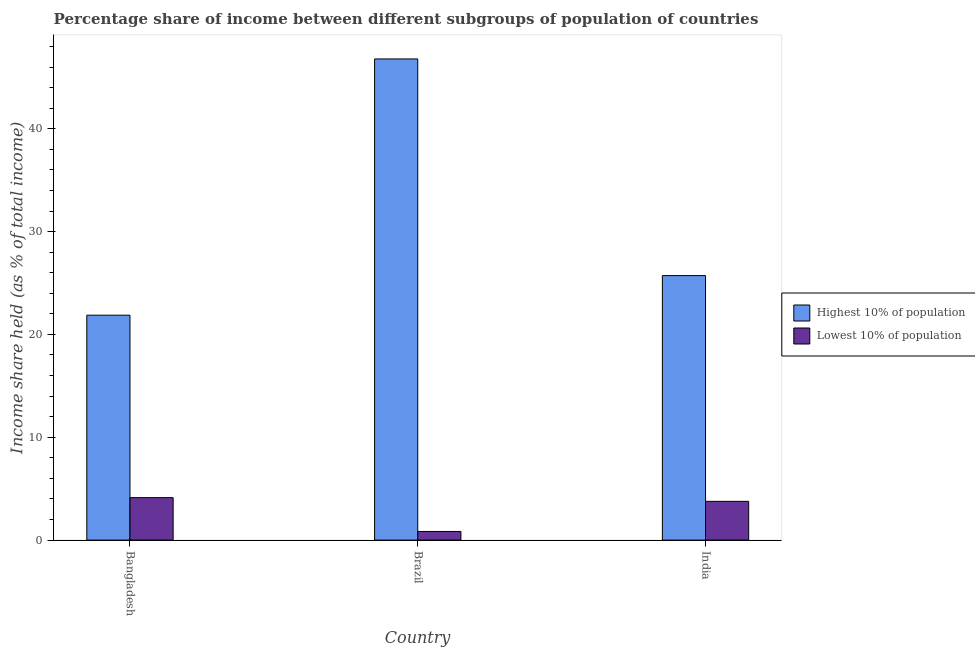How many different coloured bars are there?
Keep it short and to the point. 2. Are the number of bars on each tick of the X-axis equal?
Ensure brevity in your answer.  Yes. How many bars are there on the 2nd tick from the left?
Your answer should be very brief. 2. What is the income share held by highest 10% of the population in Bangladesh?
Offer a terse response. 21.87. Across all countries, what is the maximum income share held by lowest 10% of the population?
Give a very brief answer. 4.13. Across all countries, what is the minimum income share held by lowest 10% of the population?
Ensure brevity in your answer.  0.84. What is the total income share held by lowest 10% of the population in the graph?
Keep it short and to the point. 8.74. What is the difference between the income share held by lowest 10% of the population in Brazil and that in India?
Give a very brief answer. -2.93. What is the difference between the income share held by lowest 10% of the population in Bangladesh and the income share held by highest 10% of the population in Brazil?
Offer a very short reply. -42.66. What is the average income share held by lowest 10% of the population per country?
Give a very brief answer. 2.91. What is the difference between the income share held by highest 10% of the population and income share held by lowest 10% of the population in Bangladesh?
Offer a terse response. 17.74. In how many countries, is the income share held by lowest 10% of the population greater than 20 %?
Offer a terse response. 0. What is the ratio of the income share held by highest 10% of the population in Brazil to that in India?
Your response must be concise. 1.82. Is the income share held by lowest 10% of the population in Bangladesh less than that in Brazil?
Offer a very short reply. No. What is the difference between the highest and the second highest income share held by highest 10% of the population?
Make the answer very short. 21.07. What is the difference between the highest and the lowest income share held by highest 10% of the population?
Provide a short and direct response. 24.92. What does the 1st bar from the left in India represents?
Offer a very short reply. Highest 10% of population. What does the 2nd bar from the right in India represents?
Your answer should be compact. Highest 10% of population. How many bars are there?
Give a very brief answer. 6. Are all the bars in the graph horizontal?
Offer a terse response. No. How many countries are there in the graph?
Provide a short and direct response. 3. Where does the legend appear in the graph?
Offer a terse response. Center right. How many legend labels are there?
Provide a short and direct response. 2. How are the legend labels stacked?
Keep it short and to the point. Vertical. What is the title of the graph?
Provide a succinct answer. Percentage share of income between different subgroups of population of countries. Does "Excluding technical cooperation" appear as one of the legend labels in the graph?
Give a very brief answer. No. What is the label or title of the X-axis?
Give a very brief answer. Country. What is the label or title of the Y-axis?
Keep it short and to the point. Income share held (as % of total income). What is the Income share held (as % of total income) in Highest 10% of population in Bangladesh?
Make the answer very short. 21.87. What is the Income share held (as % of total income) in Lowest 10% of population in Bangladesh?
Your answer should be compact. 4.13. What is the Income share held (as % of total income) in Highest 10% of population in Brazil?
Your response must be concise. 46.79. What is the Income share held (as % of total income) of Lowest 10% of population in Brazil?
Keep it short and to the point. 0.84. What is the Income share held (as % of total income) in Highest 10% of population in India?
Ensure brevity in your answer.  25.72. What is the Income share held (as % of total income) in Lowest 10% of population in India?
Ensure brevity in your answer.  3.77. Across all countries, what is the maximum Income share held (as % of total income) of Highest 10% of population?
Keep it short and to the point. 46.79. Across all countries, what is the maximum Income share held (as % of total income) of Lowest 10% of population?
Offer a very short reply. 4.13. Across all countries, what is the minimum Income share held (as % of total income) of Highest 10% of population?
Offer a very short reply. 21.87. Across all countries, what is the minimum Income share held (as % of total income) of Lowest 10% of population?
Your response must be concise. 0.84. What is the total Income share held (as % of total income) in Highest 10% of population in the graph?
Give a very brief answer. 94.38. What is the total Income share held (as % of total income) of Lowest 10% of population in the graph?
Offer a very short reply. 8.74. What is the difference between the Income share held (as % of total income) of Highest 10% of population in Bangladesh and that in Brazil?
Your answer should be compact. -24.92. What is the difference between the Income share held (as % of total income) of Lowest 10% of population in Bangladesh and that in Brazil?
Provide a succinct answer. 3.29. What is the difference between the Income share held (as % of total income) in Highest 10% of population in Bangladesh and that in India?
Your answer should be compact. -3.85. What is the difference between the Income share held (as % of total income) in Lowest 10% of population in Bangladesh and that in India?
Provide a short and direct response. 0.36. What is the difference between the Income share held (as % of total income) of Highest 10% of population in Brazil and that in India?
Your answer should be compact. 21.07. What is the difference between the Income share held (as % of total income) in Lowest 10% of population in Brazil and that in India?
Keep it short and to the point. -2.93. What is the difference between the Income share held (as % of total income) of Highest 10% of population in Bangladesh and the Income share held (as % of total income) of Lowest 10% of population in Brazil?
Offer a terse response. 21.03. What is the difference between the Income share held (as % of total income) of Highest 10% of population in Bangladesh and the Income share held (as % of total income) of Lowest 10% of population in India?
Your answer should be compact. 18.1. What is the difference between the Income share held (as % of total income) in Highest 10% of population in Brazil and the Income share held (as % of total income) in Lowest 10% of population in India?
Provide a short and direct response. 43.02. What is the average Income share held (as % of total income) of Highest 10% of population per country?
Your answer should be compact. 31.46. What is the average Income share held (as % of total income) of Lowest 10% of population per country?
Provide a succinct answer. 2.91. What is the difference between the Income share held (as % of total income) of Highest 10% of population and Income share held (as % of total income) of Lowest 10% of population in Bangladesh?
Keep it short and to the point. 17.74. What is the difference between the Income share held (as % of total income) in Highest 10% of population and Income share held (as % of total income) in Lowest 10% of population in Brazil?
Your answer should be compact. 45.95. What is the difference between the Income share held (as % of total income) in Highest 10% of population and Income share held (as % of total income) in Lowest 10% of population in India?
Provide a short and direct response. 21.95. What is the ratio of the Income share held (as % of total income) of Highest 10% of population in Bangladesh to that in Brazil?
Offer a terse response. 0.47. What is the ratio of the Income share held (as % of total income) of Lowest 10% of population in Bangladesh to that in Brazil?
Ensure brevity in your answer.  4.92. What is the ratio of the Income share held (as % of total income) of Highest 10% of population in Bangladesh to that in India?
Make the answer very short. 0.85. What is the ratio of the Income share held (as % of total income) of Lowest 10% of population in Bangladesh to that in India?
Make the answer very short. 1.1. What is the ratio of the Income share held (as % of total income) of Highest 10% of population in Brazil to that in India?
Your response must be concise. 1.82. What is the ratio of the Income share held (as % of total income) in Lowest 10% of population in Brazil to that in India?
Make the answer very short. 0.22. What is the difference between the highest and the second highest Income share held (as % of total income) in Highest 10% of population?
Your response must be concise. 21.07. What is the difference between the highest and the second highest Income share held (as % of total income) in Lowest 10% of population?
Provide a succinct answer. 0.36. What is the difference between the highest and the lowest Income share held (as % of total income) in Highest 10% of population?
Provide a succinct answer. 24.92. What is the difference between the highest and the lowest Income share held (as % of total income) of Lowest 10% of population?
Make the answer very short. 3.29. 